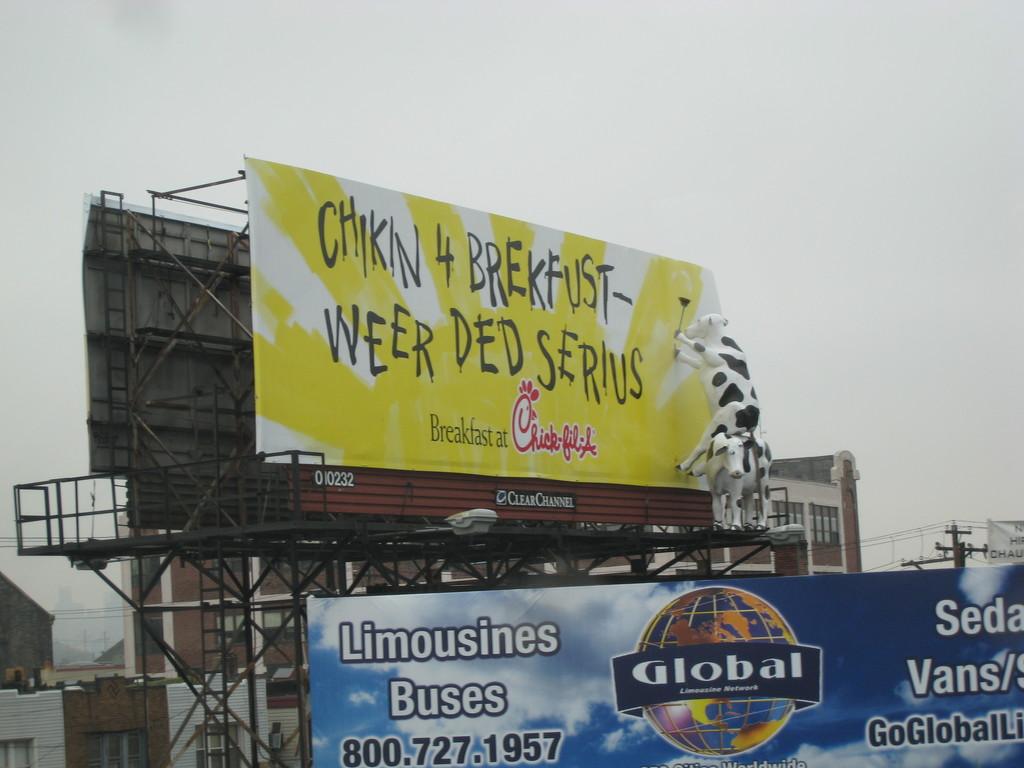What is global limousine network's phone number?
Offer a very short reply. 800.727.1957. What fast food is being displayed on the bill board?
Ensure brevity in your answer.  Chick-fil-a. 